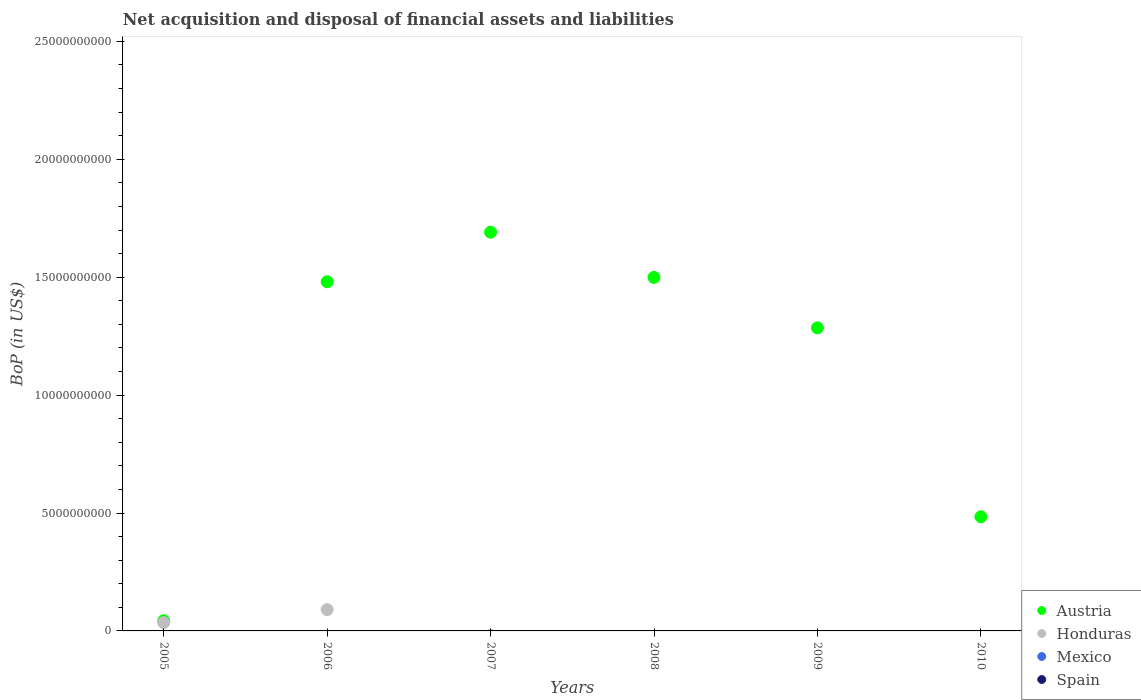How many different coloured dotlines are there?
Offer a very short reply. 2. Is the number of dotlines equal to the number of legend labels?
Offer a very short reply. No. What is the Balance of Payments in Honduras in 2008?
Give a very brief answer. 0. Across all years, what is the maximum Balance of Payments in Austria?
Ensure brevity in your answer.  1.69e+1. Across all years, what is the minimum Balance of Payments in Honduras?
Your answer should be very brief. 0. In which year was the Balance of Payments in Honduras maximum?
Provide a succinct answer. 2006. What is the total Balance of Payments in Austria in the graph?
Your answer should be compact. 6.48e+1. What is the difference between the Balance of Payments in Austria in 2007 and that in 2008?
Offer a terse response. 1.92e+09. What is the difference between the Balance of Payments in Honduras in 2008 and the Balance of Payments in Mexico in 2009?
Make the answer very short. 0. What is the average Balance of Payments in Austria per year?
Offer a terse response. 1.08e+1. In how many years, is the Balance of Payments in Austria greater than 8000000000 US$?
Your answer should be compact. 4. Is the Balance of Payments in Austria in 2005 less than that in 2006?
Give a very brief answer. Yes. What is the difference between the highest and the second highest Balance of Payments in Austria?
Provide a short and direct response. 1.92e+09. What is the difference between the highest and the lowest Balance of Payments in Austria?
Give a very brief answer. 1.65e+1. In how many years, is the Balance of Payments in Austria greater than the average Balance of Payments in Austria taken over all years?
Your answer should be very brief. 4. Is it the case that in every year, the sum of the Balance of Payments in Mexico and Balance of Payments in Spain  is greater than the sum of Balance of Payments in Austria and Balance of Payments in Honduras?
Your answer should be very brief. No. Is the Balance of Payments in Honduras strictly less than the Balance of Payments in Austria over the years?
Provide a succinct answer. Yes. How many dotlines are there?
Ensure brevity in your answer.  2. How many years are there in the graph?
Your answer should be very brief. 6. What is the difference between two consecutive major ticks on the Y-axis?
Your response must be concise. 5.00e+09. Are the values on the major ticks of Y-axis written in scientific E-notation?
Ensure brevity in your answer.  No. Does the graph contain grids?
Ensure brevity in your answer.  No. Where does the legend appear in the graph?
Make the answer very short. Bottom right. How many legend labels are there?
Your answer should be compact. 4. What is the title of the graph?
Your answer should be compact. Net acquisition and disposal of financial assets and liabilities. Does "Lower middle income" appear as one of the legend labels in the graph?
Offer a terse response. No. What is the label or title of the X-axis?
Ensure brevity in your answer.  Years. What is the label or title of the Y-axis?
Your answer should be compact. BoP (in US$). What is the BoP (in US$) in Austria in 2005?
Keep it short and to the point. 4.32e+08. What is the BoP (in US$) of Honduras in 2005?
Your answer should be very brief. 3.52e+08. What is the BoP (in US$) of Mexico in 2005?
Offer a terse response. 0. What is the BoP (in US$) in Austria in 2006?
Offer a terse response. 1.48e+1. What is the BoP (in US$) of Honduras in 2006?
Ensure brevity in your answer.  9.04e+08. What is the BoP (in US$) of Spain in 2006?
Make the answer very short. 0. What is the BoP (in US$) in Austria in 2007?
Your answer should be compact. 1.69e+1. What is the BoP (in US$) in Honduras in 2007?
Offer a terse response. 0. What is the BoP (in US$) of Mexico in 2007?
Offer a very short reply. 0. What is the BoP (in US$) in Spain in 2007?
Provide a short and direct response. 0. What is the BoP (in US$) of Austria in 2008?
Give a very brief answer. 1.50e+1. What is the BoP (in US$) of Honduras in 2008?
Your answer should be compact. 0. What is the BoP (in US$) of Mexico in 2008?
Provide a short and direct response. 0. What is the BoP (in US$) in Austria in 2009?
Provide a short and direct response. 1.29e+1. What is the BoP (in US$) in Mexico in 2009?
Offer a terse response. 0. What is the BoP (in US$) of Austria in 2010?
Provide a short and direct response. 4.84e+09. What is the BoP (in US$) of Honduras in 2010?
Offer a terse response. 0. What is the BoP (in US$) of Spain in 2010?
Your response must be concise. 0. Across all years, what is the maximum BoP (in US$) of Austria?
Offer a terse response. 1.69e+1. Across all years, what is the maximum BoP (in US$) of Honduras?
Your answer should be very brief. 9.04e+08. Across all years, what is the minimum BoP (in US$) in Austria?
Your response must be concise. 4.32e+08. What is the total BoP (in US$) in Austria in the graph?
Give a very brief answer. 6.48e+1. What is the total BoP (in US$) in Honduras in the graph?
Keep it short and to the point. 1.26e+09. What is the total BoP (in US$) in Mexico in the graph?
Your response must be concise. 0. What is the difference between the BoP (in US$) in Austria in 2005 and that in 2006?
Make the answer very short. -1.44e+1. What is the difference between the BoP (in US$) in Honduras in 2005 and that in 2006?
Provide a short and direct response. -5.52e+08. What is the difference between the BoP (in US$) of Austria in 2005 and that in 2007?
Give a very brief answer. -1.65e+1. What is the difference between the BoP (in US$) of Austria in 2005 and that in 2008?
Provide a succinct answer. -1.46e+1. What is the difference between the BoP (in US$) in Austria in 2005 and that in 2009?
Give a very brief answer. -1.24e+1. What is the difference between the BoP (in US$) of Austria in 2005 and that in 2010?
Provide a succinct answer. -4.41e+09. What is the difference between the BoP (in US$) in Austria in 2006 and that in 2007?
Ensure brevity in your answer.  -2.10e+09. What is the difference between the BoP (in US$) in Austria in 2006 and that in 2008?
Your answer should be compact. -1.83e+08. What is the difference between the BoP (in US$) in Austria in 2006 and that in 2009?
Give a very brief answer. 1.96e+09. What is the difference between the BoP (in US$) in Austria in 2006 and that in 2010?
Provide a succinct answer. 9.97e+09. What is the difference between the BoP (in US$) in Austria in 2007 and that in 2008?
Keep it short and to the point. 1.92e+09. What is the difference between the BoP (in US$) of Austria in 2007 and that in 2009?
Give a very brief answer. 4.06e+09. What is the difference between the BoP (in US$) in Austria in 2007 and that in 2010?
Your response must be concise. 1.21e+1. What is the difference between the BoP (in US$) of Austria in 2008 and that in 2009?
Give a very brief answer. 2.14e+09. What is the difference between the BoP (in US$) in Austria in 2008 and that in 2010?
Make the answer very short. 1.01e+1. What is the difference between the BoP (in US$) in Austria in 2009 and that in 2010?
Offer a very short reply. 8.01e+09. What is the difference between the BoP (in US$) in Austria in 2005 and the BoP (in US$) in Honduras in 2006?
Your answer should be very brief. -4.72e+08. What is the average BoP (in US$) of Austria per year?
Offer a terse response. 1.08e+1. What is the average BoP (in US$) in Honduras per year?
Your answer should be compact. 2.09e+08. What is the average BoP (in US$) in Spain per year?
Your response must be concise. 0. In the year 2005, what is the difference between the BoP (in US$) of Austria and BoP (in US$) of Honduras?
Make the answer very short. 8.03e+07. In the year 2006, what is the difference between the BoP (in US$) of Austria and BoP (in US$) of Honduras?
Offer a terse response. 1.39e+1. What is the ratio of the BoP (in US$) of Austria in 2005 to that in 2006?
Provide a succinct answer. 0.03. What is the ratio of the BoP (in US$) in Honduras in 2005 to that in 2006?
Give a very brief answer. 0.39. What is the ratio of the BoP (in US$) in Austria in 2005 to that in 2007?
Your answer should be compact. 0.03. What is the ratio of the BoP (in US$) in Austria in 2005 to that in 2008?
Provide a succinct answer. 0.03. What is the ratio of the BoP (in US$) of Austria in 2005 to that in 2009?
Your response must be concise. 0.03. What is the ratio of the BoP (in US$) in Austria in 2005 to that in 2010?
Offer a very short reply. 0.09. What is the ratio of the BoP (in US$) of Austria in 2006 to that in 2007?
Keep it short and to the point. 0.88. What is the ratio of the BoP (in US$) of Austria in 2006 to that in 2008?
Your answer should be very brief. 0.99. What is the ratio of the BoP (in US$) of Austria in 2006 to that in 2009?
Provide a short and direct response. 1.15. What is the ratio of the BoP (in US$) in Austria in 2006 to that in 2010?
Make the answer very short. 3.06. What is the ratio of the BoP (in US$) in Austria in 2007 to that in 2008?
Offer a very short reply. 1.13. What is the ratio of the BoP (in US$) of Austria in 2007 to that in 2009?
Your answer should be compact. 1.32. What is the ratio of the BoP (in US$) of Austria in 2007 to that in 2010?
Provide a short and direct response. 3.49. What is the ratio of the BoP (in US$) in Austria in 2008 to that in 2009?
Your answer should be very brief. 1.17. What is the ratio of the BoP (in US$) of Austria in 2008 to that in 2010?
Your answer should be compact. 3.1. What is the ratio of the BoP (in US$) of Austria in 2009 to that in 2010?
Offer a very short reply. 2.65. What is the difference between the highest and the second highest BoP (in US$) in Austria?
Give a very brief answer. 1.92e+09. What is the difference between the highest and the lowest BoP (in US$) in Austria?
Your answer should be compact. 1.65e+1. What is the difference between the highest and the lowest BoP (in US$) in Honduras?
Provide a succinct answer. 9.04e+08. 